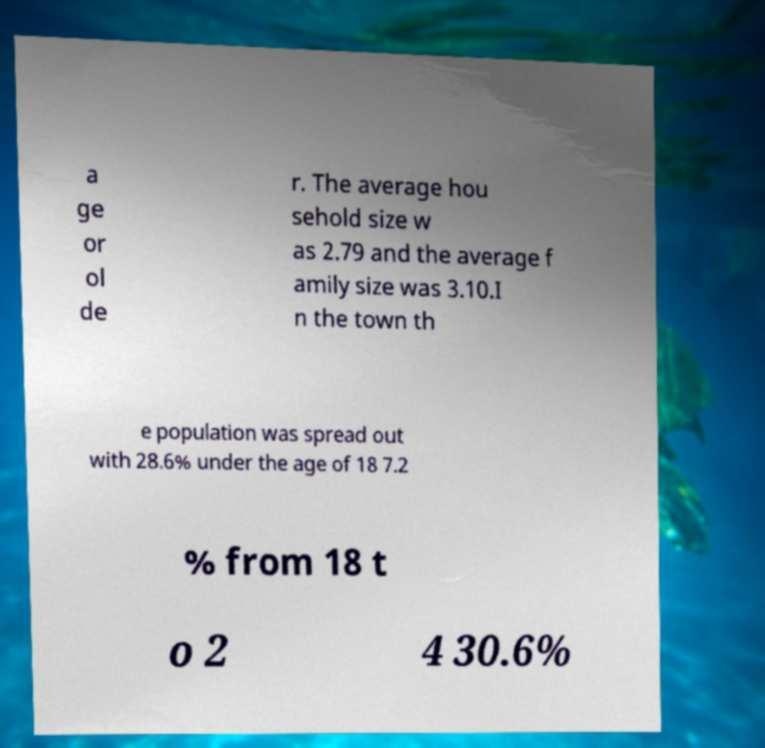Could you extract and type out the text from this image? a ge or ol de r. The average hou sehold size w as 2.79 and the average f amily size was 3.10.I n the town th e population was spread out with 28.6% under the age of 18 7.2 % from 18 t o 2 4 30.6% 